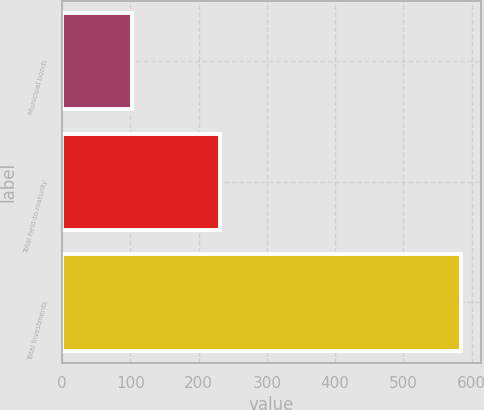Convert chart. <chart><loc_0><loc_0><loc_500><loc_500><bar_chart><fcel>Municipal bonds<fcel>Total held-to-maturity<fcel>Total Investments<nl><fcel>102.2<fcel>230.8<fcel>584.1<nl></chart> 